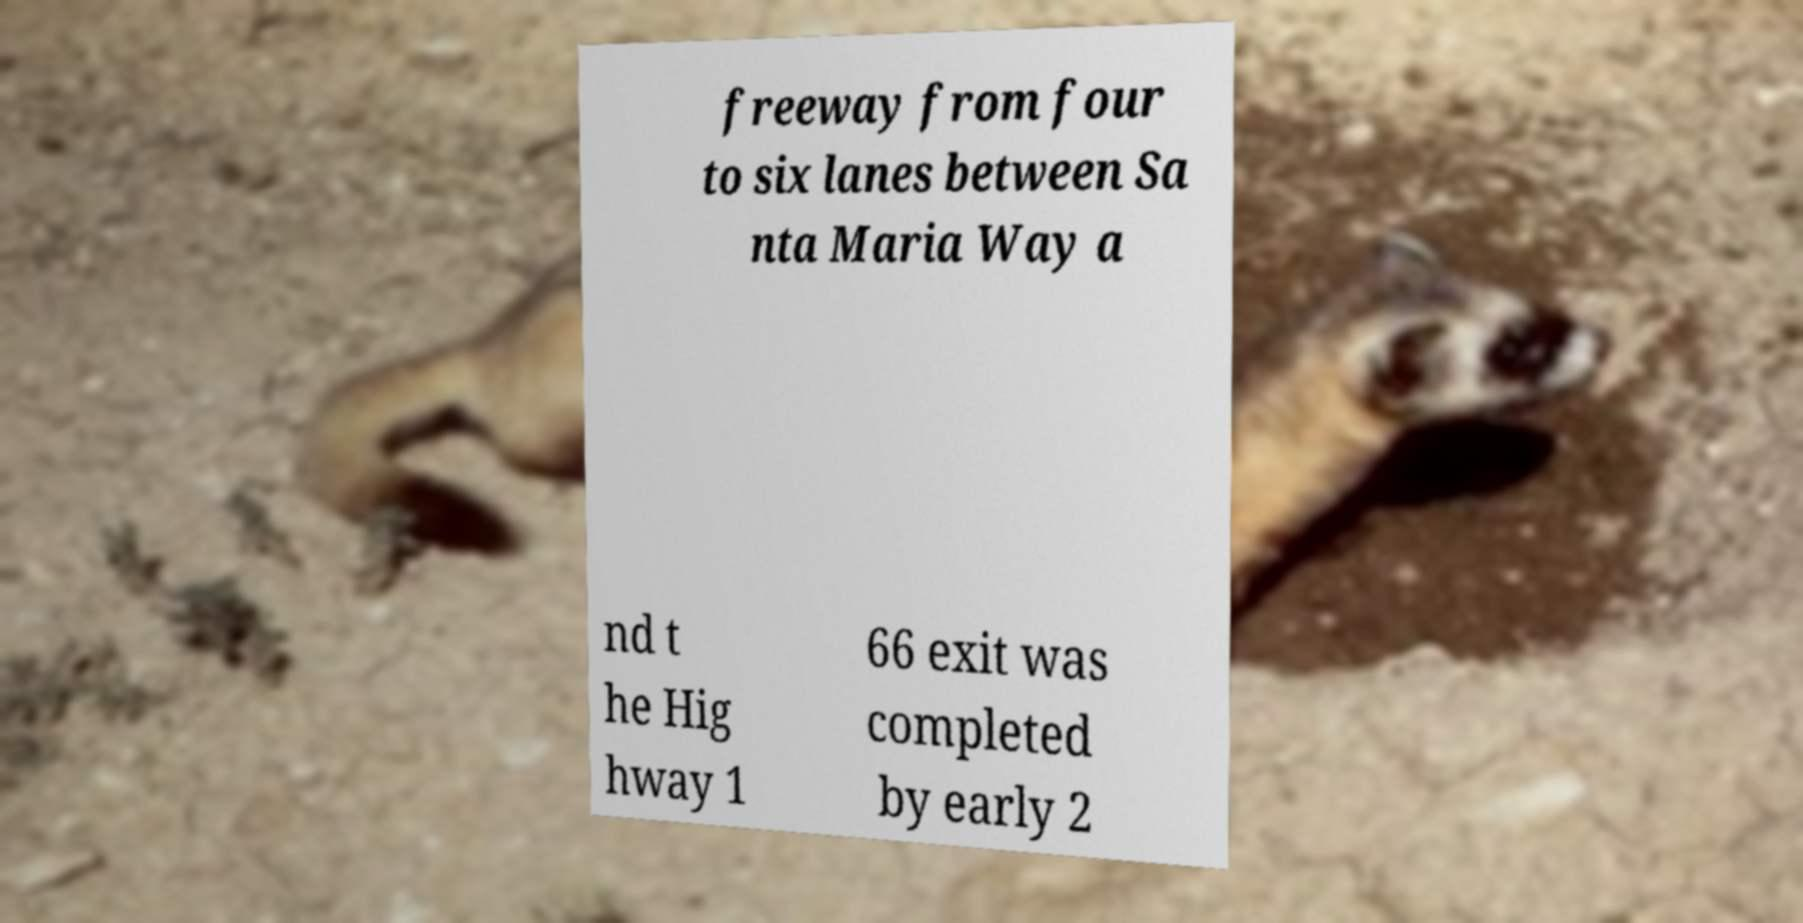Could you extract and type out the text from this image? freeway from four to six lanes between Sa nta Maria Way a nd t he Hig hway 1 66 exit was completed by early 2 